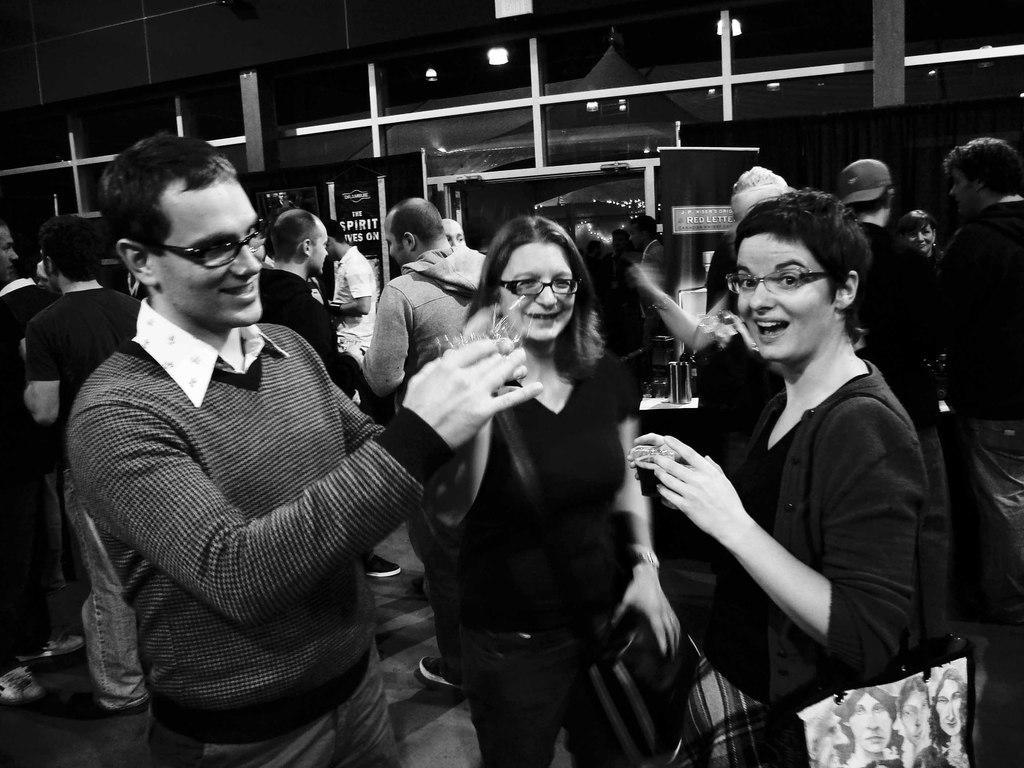How would you summarize this image in a sentence or two? In this picture I can observe some people standing on the floor. There are men and women in this picture. This is a black and white image. 